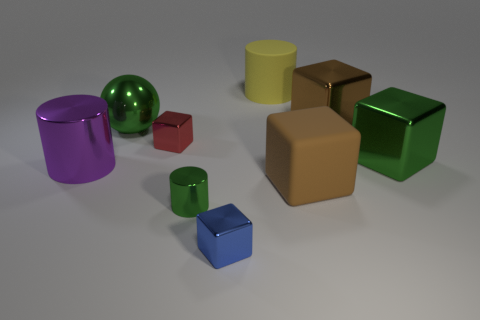Subtract all brown cubes. How many were subtracted if there are1brown cubes left? 1 Subtract all large cylinders. How many cylinders are left? 1 Subtract all blue balls. How many brown blocks are left? 2 Subtract all green blocks. How many blocks are left? 4 Subtract 1 cylinders. How many cylinders are left? 2 Add 1 brown shiny objects. How many objects exist? 10 Subtract all balls. How many objects are left? 8 Subtract all yellow blocks. Subtract all blue cylinders. How many blocks are left? 5 Add 3 small brown cylinders. How many small brown cylinders exist? 3 Subtract 0 red cylinders. How many objects are left? 9 